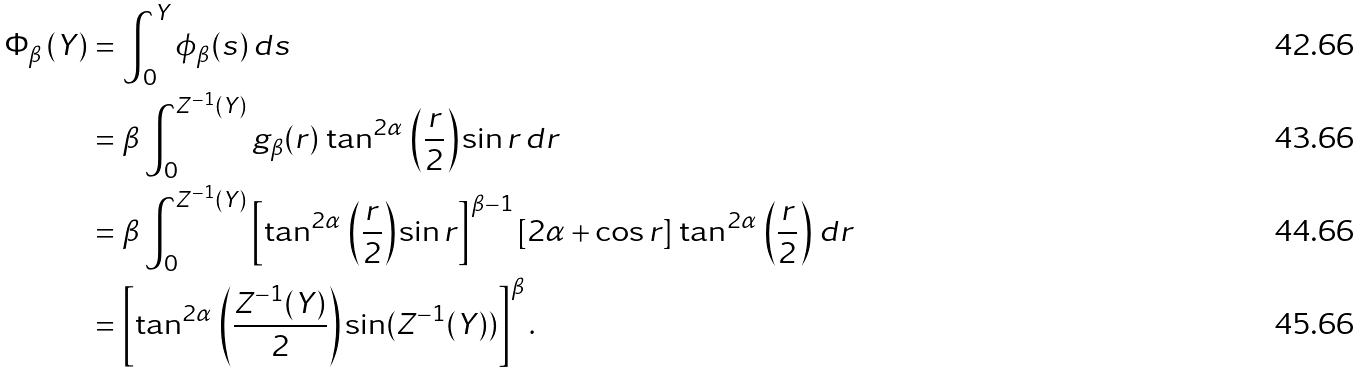Convert formula to latex. <formula><loc_0><loc_0><loc_500><loc_500>\Phi _ { \beta } \left ( Y \right ) & = \int _ { 0 } ^ { Y } \phi _ { \beta } ( s ) \, d s \\ & = \beta \int _ { 0 } ^ { Z ^ { - 1 } ( Y ) } g _ { \beta } ( r ) \, \tan ^ { 2 \alpha } \, \left ( \frac { r } { 2 } \right ) \sin r \, d r \\ & = \beta \int _ { 0 } ^ { Z ^ { - 1 } ( Y ) } \left [ \tan ^ { 2 \alpha } \, \left ( \frac { r } { 2 } \right ) { \sin r } \right ] ^ { \beta - 1 } \left [ { 2 \alpha + \cos r } \right ] \, \tan ^ { 2 \alpha } \, \left ( \frac { r } { 2 } \right ) \, d r \\ & = \left [ \tan ^ { 2 \alpha } \, \left ( \frac { Z ^ { - 1 } ( Y ) } { 2 } \right ) { \sin ( Z ^ { - 1 } ( Y ) ) } \right ] ^ { \beta } .</formula> 